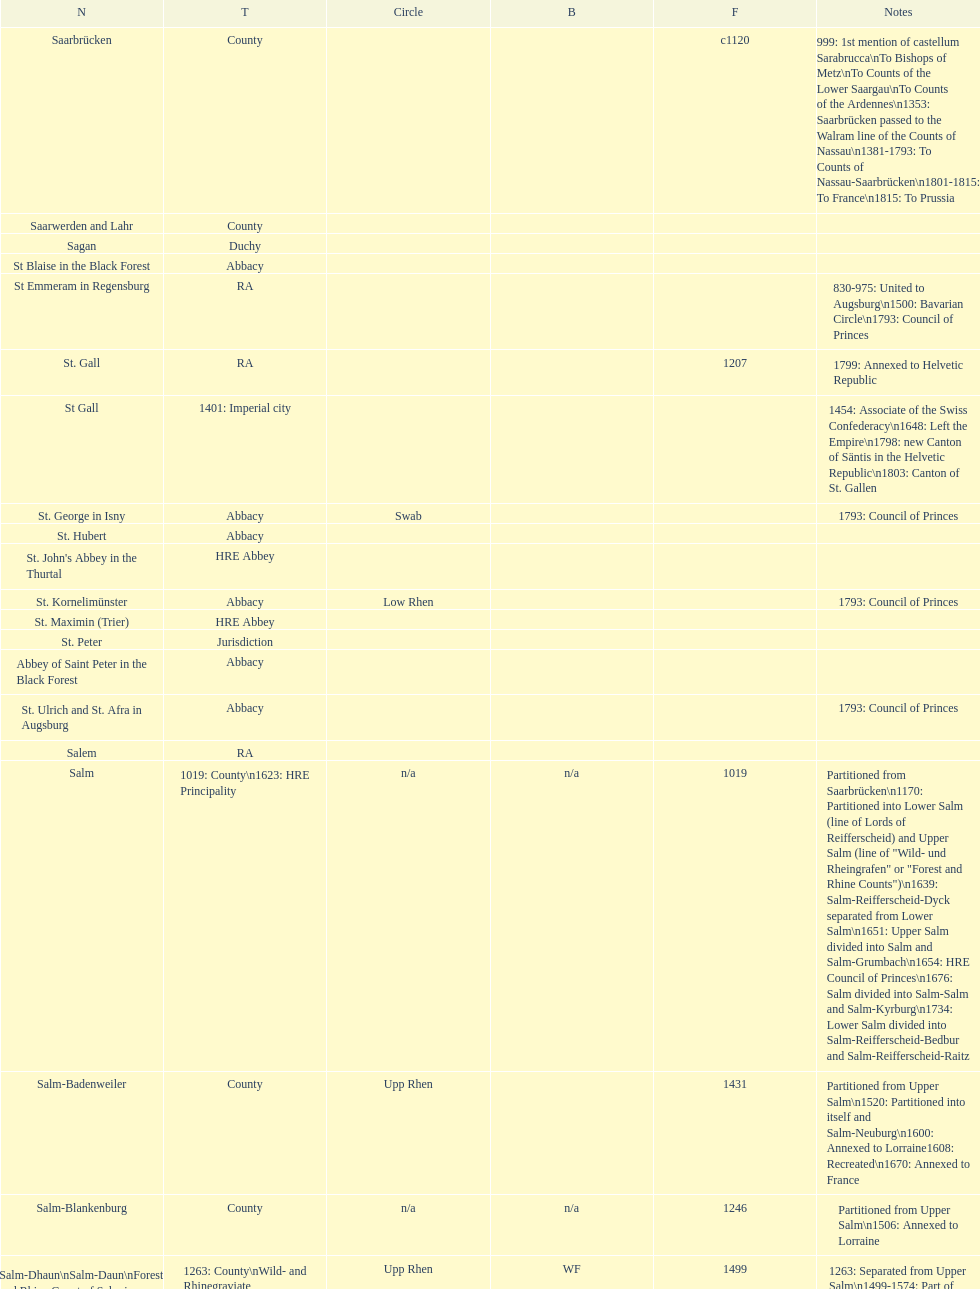What is the state above "sagan"? Saarwerden and Lahr. 